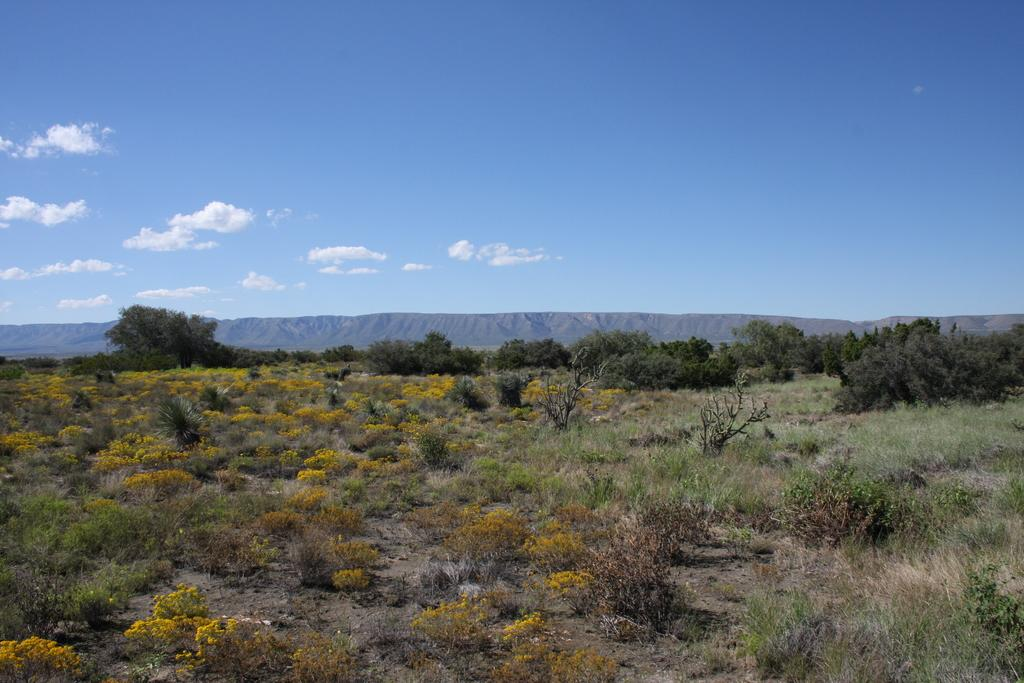What type of vegetation can be seen in the image? There are trees and grass in the image. Are there any specific flowers visible in the image? Yes, there are yellow flowers in the image. What type of landscape feature is present in the background of the image? There are mountains in the image. What is the color of the sky in the image? The sky is blue and white in color. Can you see a kite flying in the sky in the image? No, there is no kite visible in the image. Is there any indication that the image was taken in space? No, there is no indication that the image was taken in space; it features a landscape with trees, grass, mountains, and a blue and white sky. 